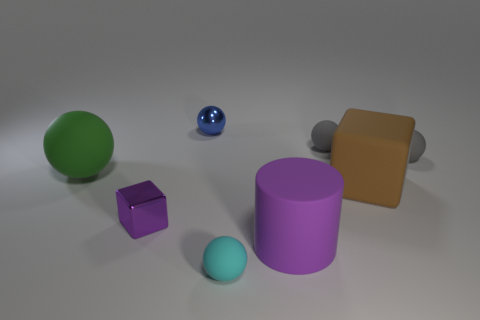What is the size of the matte thing that is the same color as the small block?
Ensure brevity in your answer.  Large. Do the matte sphere that is in front of the big brown rubber thing and the purple cylinder to the right of the green thing have the same size?
Ensure brevity in your answer.  No. Is the number of tiny rubber things that are behind the large rubber sphere greater than the number of cyan balls that are left of the brown rubber cube?
Give a very brief answer. Yes. Are there any cyan things made of the same material as the tiny blue object?
Give a very brief answer. No. Is the color of the cylinder the same as the tiny shiny cube?
Your response must be concise. Yes. The thing that is behind the small purple block and left of the blue shiny thing is made of what material?
Your response must be concise. Rubber. The big block is what color?
Your answer should be compact. Brown. How many small purple shiny things are the same shape as the brown rubber object?
Ensure brevity in your answer.  1. Does the sphere in front of the tiny purple block have the same material as the big sphere behind the big purple rubber thing?
Give a very brief answer. Yes. There is a cube that is behind the tiny shiny object that is in front of the green ball; how big is it?
Give a very brief answer. Large. 